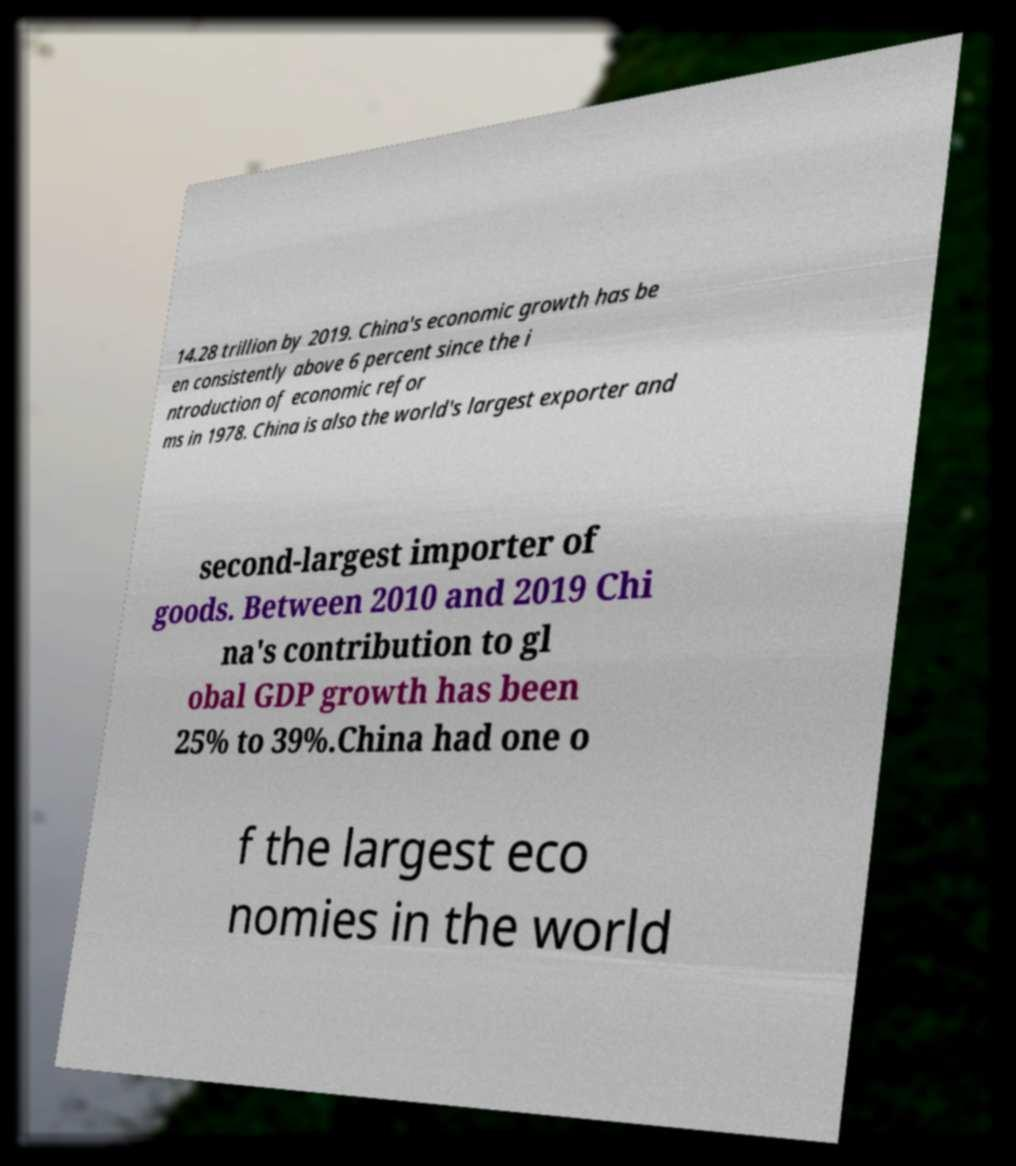There's text embedded in this image that I need extracted. Can you transcribe it verbatim? 14.28 trillion by 2019. China's economic growth has be en consistently above 6 percent since the i ntroduction of economic refor ms in 1978. China is also the world's largest exporter and second-largest importer of goods. Between 2010 and 2019 Chi na's contribution to gl obal GDP growth has been 25% to 39%.China had one o f the largest eco nomies in the world 